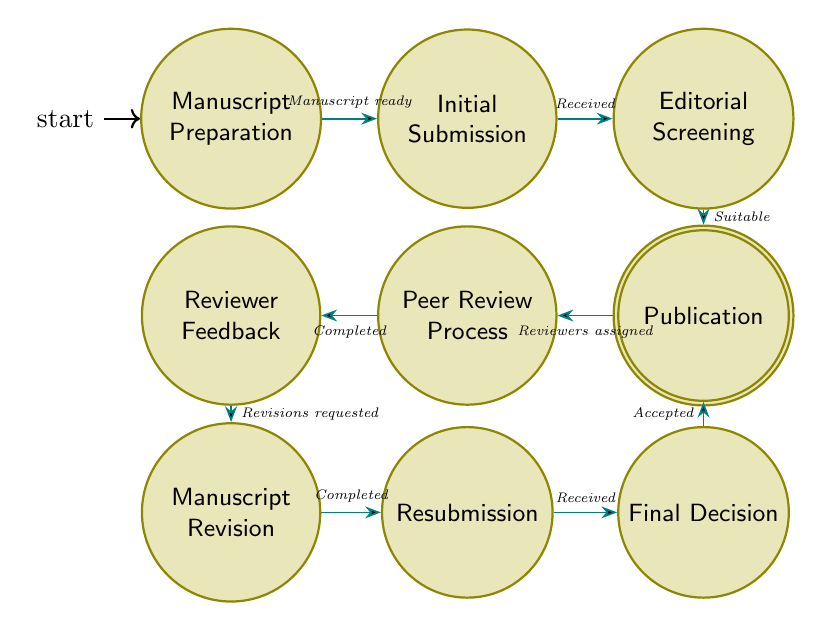What is the first state in the process? The first state, as indicated in the diagram, is where the manuscript is compiled and prepared for submission. This is clearly labeled as "Manuscript Preparation".
Answer: Manuscript Preparation How many states are present in the diagram? By counting each labeled state within the diagram, we find that there are a total of ten distinct states involved in the peer review process.
Answer: Ten What must happen before moving from "Initial Submission" to "Editorial Screening"? The transition from "Initial Submission" to "Editorial Screening" requires that the manuscript be received by the journal, as indicated in the transition label.
Answer: Manuscript received What is the condition for transitioning to "Peer Review Assignment"? The condition for moving to "Peer Review Assignment" is that the manuscript has been deemed suitable for peer review, as noted in the diagram.
Answer: Manuscript deemed suitable for peer review What happens after receiving "Reviewer Feedback"? Following the reception of "Reviewer Feedback", the next step involves requesting revisions to the manuscript. This is evident as it leads to the state "Manuscript Revision".
Answer: Revisions requested If the manuscript is accepted, what is the final state? If the manuscript is accepted, the final state in the process is "Publication", where the accepted manuscript goes through the publication process.
Answer: Publication What transition follows the state "Manuscript Revision"? After completing revisions on the manuscript, the next transition is to "Resubmission", indicating that the revised manuscript is submitted again to the journal.
Answer: Resubmission Which state involves the evaluation of the manuscript by experts? The state that involves evaluation by experts, specifically the peer reviewers, is "Peer Review Process" where the manuscript is assessed based on various criteria.
Answer: Peer Review Process What is required for the "Final Decision" state to occur? The "Final Decision" state happens after the revised manuscript is received by the journal, indicating the process of making a final decision on acceptance or further revisions.
Answer: Revised manuscript received by the journal 